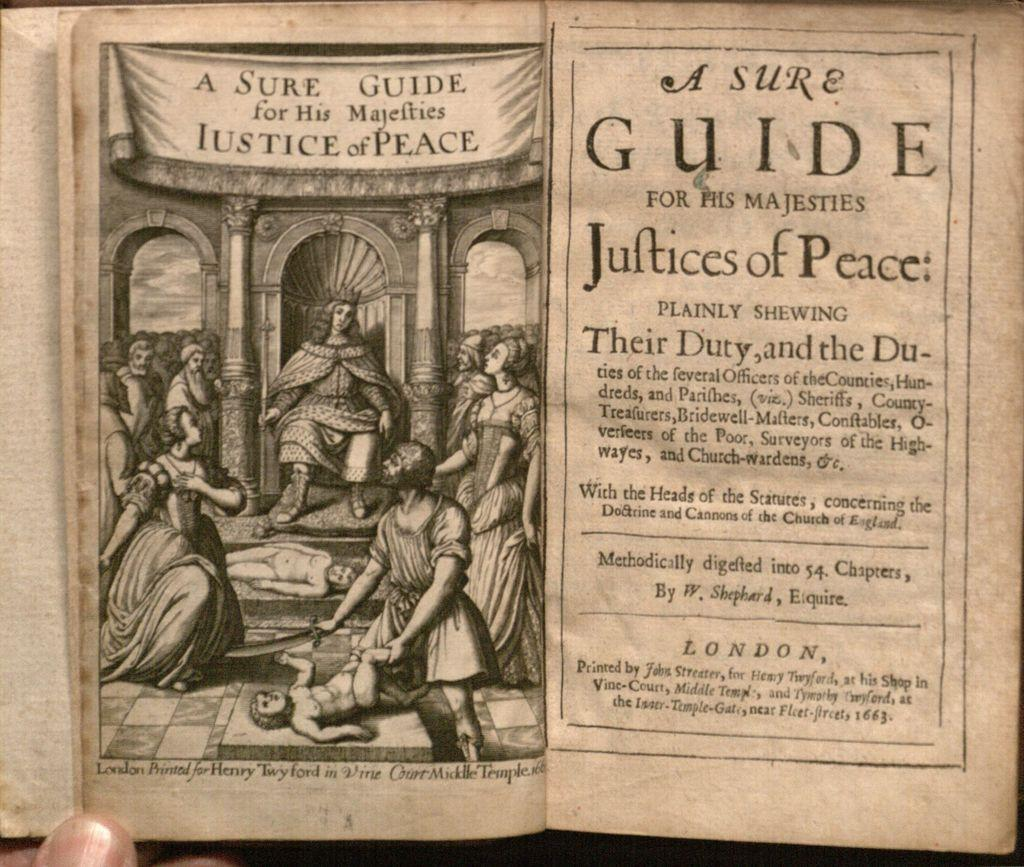<image>
Offer a succinct explanation of the picture presented. A old printed text claims to be a sure guide for his majesties justices of the peace. 